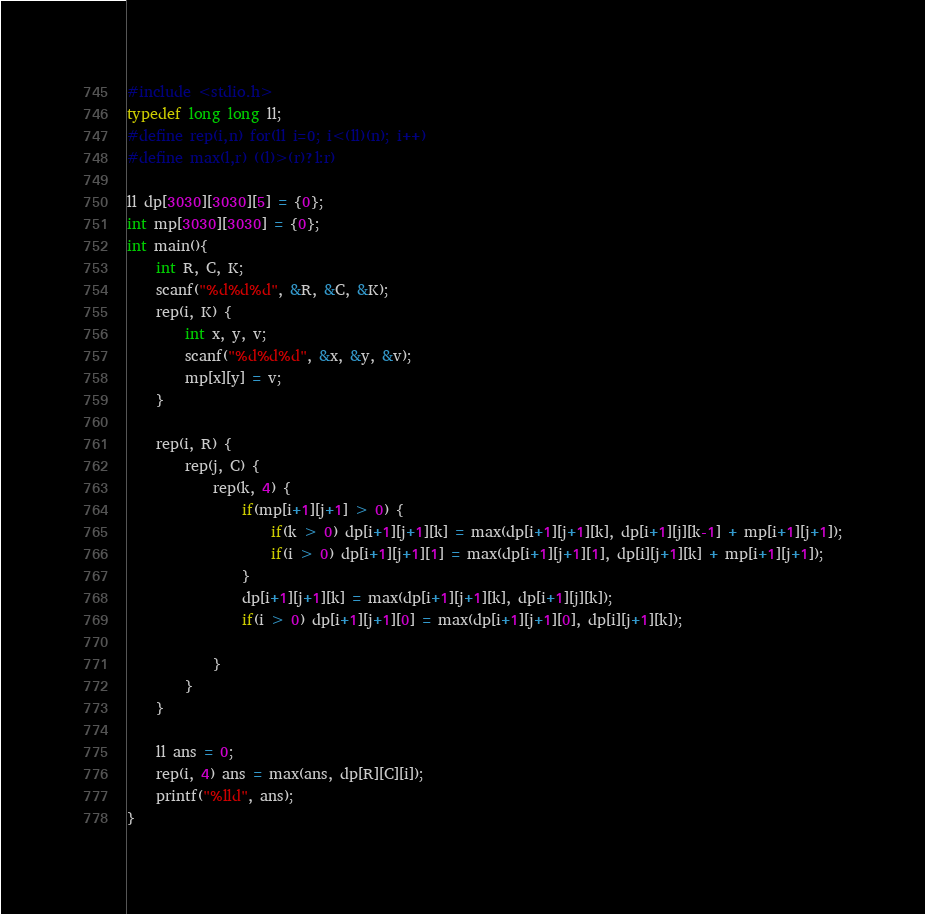Convert code to text. <code><loc_0><loc_0><loc_500><loc_500><_C_>#include <stdio.h>
typedef long long ll;
#define rep(i,n) for(ll i=0; i<(ll)(n); i++)
#define max(l,r) ((l)>(r)?l:r)

ll dp[3030][3030][5] = {0};
int mp[3030][3030] = {0};
int main(){
    int R, C, K;
    scanf("%d%d%d", &R, &C, &K);
    rep(i, K) {
        int x, y, v;
        scanf("%d%d%d", &x, &y, &v);
        mp[x][y] = v;
    }

    rep(i, R) {
        rep(j, C) {
            rep(k, 4) {
                if(mp[i+1][j+1] > 0) {
                    if(k > 0) dp[i+1][j+1][k] = max(dp[i+1][j+1][k], dp[i+1][j][k-1] + mp[i+1][j+1]);
                    if(i > 0) dp[i+1][j+1][1] = max(dp[i+1][j+1][1], dp[i][j+1][k] + mp[i+1][j+1]);
                }
                dp[i+1][j+1][k] = max(dp[i+1][j+1][k], dp[i+1][j][k]);
                if(i > 0) dp[i+1][j+1][0] = max(dp[i+1][j+1][0], dp[i][j+1][k]);
                
            }
        }
    }

    ll ans = 0;
    rep(i, 4) ans = max(ans, dp[R][C][i]);
    printf("%lld", ans);
}</code> 